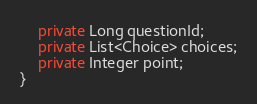<code> <loc_0><loc_0><loc_500><loc_500><_Java_>    private Long questionId;
    private List<Choice> choices;
    private Integer point;
}
</code> 